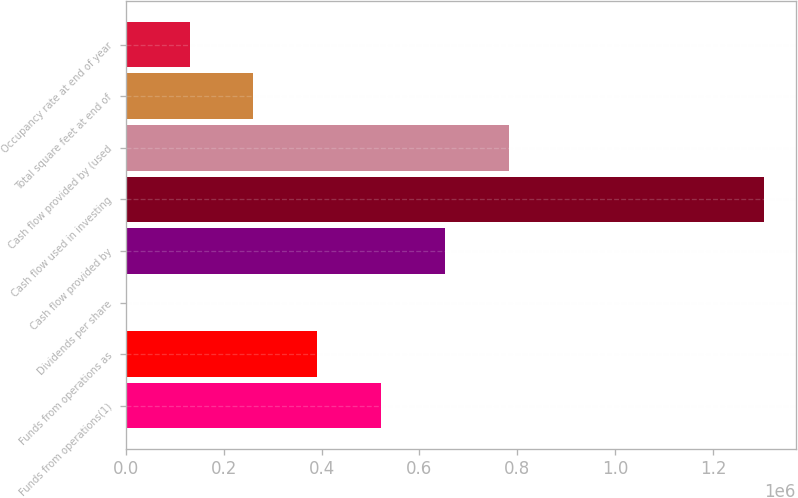Convert chart. <chart><loc_0><loc_0><loc_500><loc_500><bar_chart><fcel>Funds from operations(1)<fcel>Funds from operations as<fcel>Dividends per share<fcel>Cash flow provided by<fcel>Cash flow used in investing<fcel>Cash flow provided by (used<fcel>Total square feet at end of<fcel>Occupancy rate at end of year<nl><fcel>521450<fcel>391088<fcel>2.27<fcel>651812<fcel>1.30362e+06<fcel>782174<fcel>260726<fcel>130364<nl></chart> 